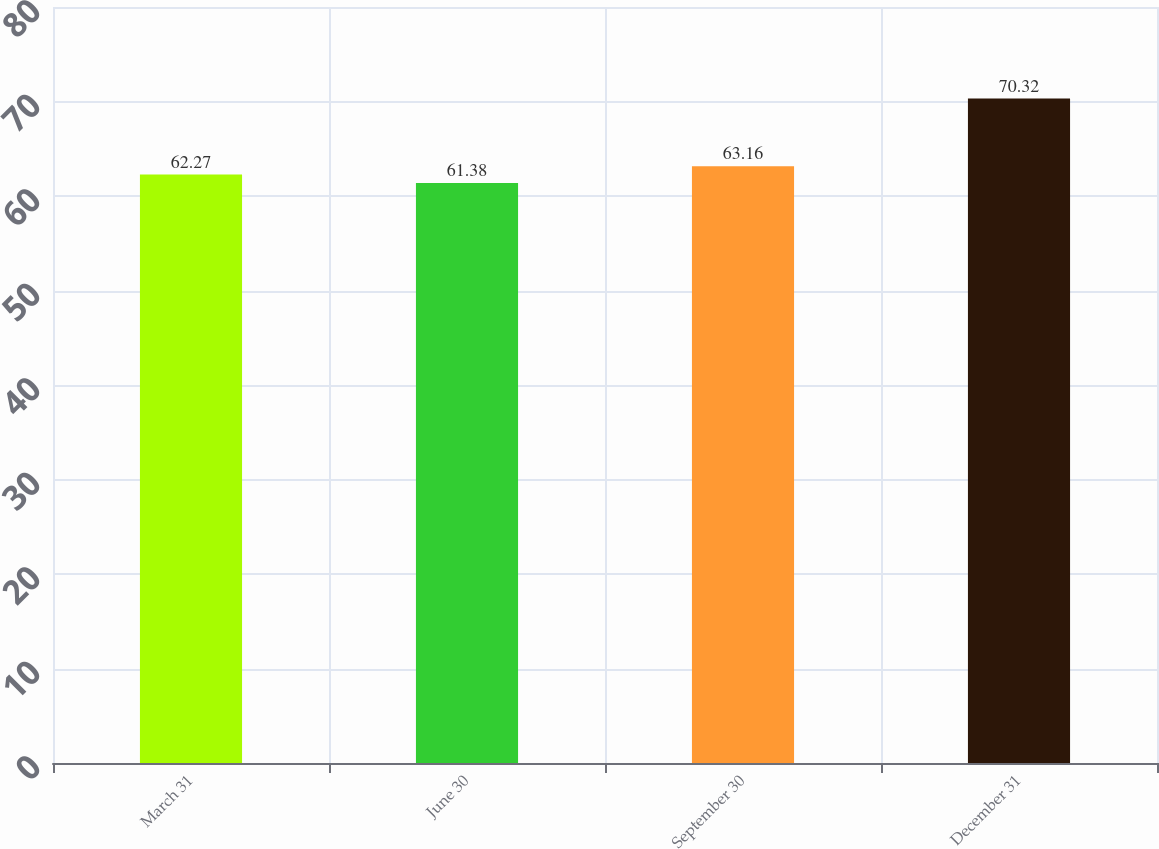<chart> <loc_0><loc_0><loc_500><loc_500><bar_chart><fcel>March 31<fcel>June 30<fcel>September 30<fcel>December 31<nl><fcel>62.27<fcel>61.38<fcel>63.16<fcel>70.32<nl></chart> 